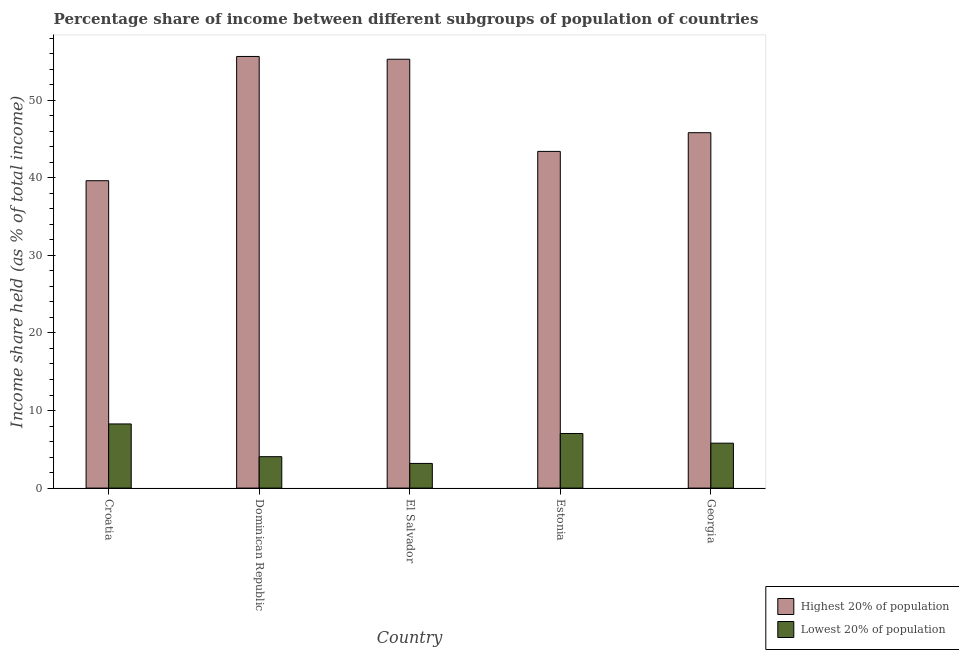How many groups of bars are there?
Provide a succinct answer. 5. How many bars are there on the 2nd tick from the left?
Offer a very short reply. 2. What is the label of the 2nd group of bars from the left?
Offer a terse response. Dominican Republic. In how many cases, is the number of bars for a given country not equal to the number of legend labels?
Your answer should be compact. 0. What is the income share held by highest 20% of the population in Croatia?
Your response must be concise. 39.63. Across all countries, what is the maximum income share held by highest 20% of the population?
Your answer should be very brief. 55.65. Across all countries, what is the minimum income share held by highest 20% of the population?
Your answer should be compact. 39.63. In which country was the income share held by lowest 20% of the population maximum?
Provide a short and direct response. Croatia. In which country was the income share held by highest 20% of the population minimum?
Your answer should be very brief. Croatia. What is the total income share held by highest 20% of the population in the graph?
Offer a terse response. 239.8. What is the difference between the income share held by lowest 20% of the population in Croatia and that in Estonia?
Your answer should be compact. 1.23. What is the difference between the income share held by highest 20% of the population in Estonia and the income share held by lowest 20% of the population in Croatia?
Provide a short and direct response. 35.14. What is the average income share held by lowest 20% of the population per country?
Ensure brevity in your answer.  5.67. What is the difference between the income share held by highest 20% of the population and income share held by lowest 20% of the population in El Salvador?
Offer a terse response. 52.11. In how many countries, is the income share held by highest 20% of the population greater than 38 %?
Give a very brief answer. 5. What is the ratio of the income share held by lowest 20% of the population in El Salvador to that in Georgia?
Your response must be concise. 0.55. Is the income share held by lowest 20% of the population in El Salvador less than that in Georgia?
Give a very brief answer. Yes. Is the difference between the income share held by lowest 20% of the population in Dominican Republic and Estonia greater than the difference between the income share held by highest 20% of the population in Dominican Republic and Estonia?
Your answer should be compact. No. What is the difference between the highest and the second highest income share held by highest 20% of the population?
Keep it short and to the point. 0.36. What is the difference between the highest and the lowest income share held by lowest 20% of the population?
Your answer should be compact. 5.09. In how many countries, is the income share held by highest 20% of the population greater than the average income share held by highest 20% of the population taken over all countries?
Offer a terse response. 2. Is the sum of the income share held by lowest 20% of the population in Croatia and El Salvador greater than the maximum income share held by highest 20% of the population across all countries?
Provide a succinct answer. No. What does the 2nd bar from the left in Estonia represents?
Provide a short and direct response. Lowest 20% of population. What does the 1st bar from the right in Croatia represents?
Ensure brevity in your answer.  Lowest 20% of population. Are all the bars in the graph horizontal?
Make the answer very short. No. How many countries are there in the graph?
Your response must be concise. 5. What is the difference between two consecutive major ticks on the Y-axis?
Keep it short and to the point. 10. Are the values on the major ticks of Y-axis written in scientific E-notation?
Make the answer very short. No. How many legend labels are there?
Offer a terse response. 2. How are the legend labels stacked?
Offer a terse response. Vertical. What is the title of the graph?
Your answer should be very brief. Percentage share of income between different subgroups of population of countries. Does "Merchandise exports" appear as one of the legend labels in the graph?
Ensure brevity in your answer.  No. What is the label or title of the Y-axis?
Ensure brevity in your answer.  Income share held (as % of total income). What is the Income share held (as % of total income) in Highest 20% of population in Croatia?
Your answer should be very brief. 39.63. What is the Income share held (as % of total income) of Lowest 20% of population in Croatia?
Your answer should be compact. 8.27. What is the Income share held (as % of total income) of Highest 20% of population in Dominican Republic?
Give a very brief answer. 55.65. What is the Income share held (as % of total income) in Lowest 20% of population in Dominican Republic?
Offer a very short reply. 4.05. What is the Income share held (as % of total income) of Highest 20% of population in El Salvador?
Ensure brevity in your answer.  55.29. What is the Income share held (as % of total income) of Lowest 20% of population in El Salvador?
Offer a very short reply. 3.18. What is the Income share held (as % of total income) of Highest 20% of population in Estonia?
Make the answer very short. 43.41. What is the Income share held (as % of total income) of Lowest 20% of population in Estonia?
Provide a short and direct response. 7.04. What is the Income share held (as % of total income) in Highest 20% of population in Georgia?
Your response must be concise. 45.82. What is the Income share held (as % of total income) in Lowest 20% of population in Georgia?
Offer a terse response. 5.79. Across all countries, what is the maximum Income share held (as % of total income) in Highest 20% of population?
Offer a very short reply. 55.65. Across all countries, what is the maximum Income share held (as % of total income) of Lowest 20% of population?
Provide a succinct answer. 8.27. Across all countries, what is the minimum Income share held (as % of total income) in Highest 20% of population?
Your response must be concise. 39.63. Across all countries, what is the minimum Income share held (as % of total income) in Lowest 20% of population?
Your response must be concise. 3.18. What is the total Income share held (as % of total income) in Highest 20% of population in the graph?
Provide a succinct answer. 239.8. What is the total Income share held (as % of total income) in Lowest 20% of population in the graph?
Give a very brief answer. 28.33. What is the difference between the Income share held (as % of total income) of Highest 20% of population in Croatia and that in Dominican Republic?
Keep it short and to the point. -16.02. What is the difference between the Income share held (as % of total income) in Lowest 20% of population in Croatia and that in Dominican Republic?
Ensure brevity in your answer.  4.22. What is the difference between the Income share held (as % of total income) in Highest 20% of population in Croatia and that in El Salvador?
Your answer should be compact. -15.66. What is the difference between the Income share held (as % of total income) of Lowest 20% of population in Croatia and that in El Salvador?
Your answer should be compact. 5.09. What is the difference between the Income share held (as % of total income) of Highest 20% of population in Croatia and that in Estonia?
Make the answer very short. -3.78. What is the difference between the Income share held (as % of total income) of Lowest 20% of population in Croatia and that in Estonia?
Your answer should be very brief. 1.23. What is the difference between the Income share held (as % of total income) of Highest 20% of population in Croatia and that in Georgia?
Provide a short and direct response. -6.19. What is the difference between the Income share held (as % of total income) of Lowest 20% of population in Croatia and that in Georgia?
Offer a terse response. 2.48. What is the difference between the Income share held (as % of total income) of Highest 20% of population in Dominican Republic and that in El Salvador?
Your answer should be very brief. 0.36. What is the difference between the Income share held (as % of total income) of Lowest 20% of population in Dominican Republic and that in El Salvador?
Offer a terse response. 0.87. What is the difference between the Income share held (as % of total income) in Highest 20% of population in Dominican Republic and that in Estonia?
Your answer should be compact. 12.24. What is the difference between the Income share held (as % of total income) of Lowest 20% of population in Dominican Republic and that in Estonia?
Your response must be concise. -2.99. What is the difference between the Income share held (as % of total income) of Highest 20% of population in Dominican Republic and that in Georgia?
Offer a terse response. 9.83. What is the difference between the Income share held (as % of total income) in Lowest 20% of population in Dominican Republic and that in Georgia?
Keep it short and to the point. -1.74. What is the difference between the Income share held (as % of total income) in Highest 20% of population in El Salvador and that in Estonia?
Your answer should be compact. 11.88. What is the difference between the Income share held (as % of total income) in Lowest 20% of population in El Salvador and that in Estonia?
Offer a terse response. -3.86. What is the difference between the Income share held (as % of total income) in Highest 20% of population in El Salvador and that in Georgia?
Offer a very short reply. 9.47. What is the difference between the Income share held (as % of total income) in Lowest 20% of population in El Salvador and that in Georgia?
Your answer should be compact. -2.61. What is the difference between the Income share held (as % of total income) in Highest 20% of population in Estonia and that in Georgia?
Keep it short and to the point. -2.41. What is the difference between the Income share held (as % of total income) in Lowest 20% of population in Estonia and that in Georgia?
Offer a terse response. 1.25. What is the difference between the Income share held (as % of total income) of Highest 20% of population in Croatia and the Income share held (as % of total income) of Lowest 20% of population in Dominican Republic?
Ensure brevity in your answer.  35.58. What is the difference between the Income share held (as % of total income) in Highest 20% of population in Croatia and the Income share held (as % of total income) in Lowest 20% of population in El Salvador?
Your answer should be very brief. 36.45. What is the difference between the Income share held (as % of total income) in Highest 20% of population in Croatia and the Income share held (as % of total income) in Lowest 20% of population in Estonia?
Make the answer very short. 32.59. What is the difference between the Income share held (as % of total income) of Highest 20% of population in Croatia and the Income share held (as % of total income) of Lowest 20% of population in Georgia?
Offer a very short reply. 33.84. What is the difference between the Income share held (as % of total income) of Highest 20% of population in Dominican Republic and the Income share held (as % of total income) of Lowest 20% of population in El Salvador?
Your answer should be very brief. 52.47. What is the difference between the Income share held (as % of total income) in Highest 20% of population in Dominican Republic and the Income share held (as % of total income) in Lowest 20% of population in Estonia?
Make the answer very short. 48.61. What is the difference between the Income share held (as % of total income) in Highest 20% of population in Dominican Republic and the Income share held (as % of total income) in Lowest 20% of population in Georgia?
Keep it short and to the point. 49.86. What is the difference between the Income share held (as % of total income) of Highest 20% of population in El Salvador and the Income share held (as % of total income) of Lowest 20% of population in Estonia?
Ensure brevity in your answer.  48.25. What is the difference between the Income share held (as % of total income) in Highest 20% of population in El Salvador and the Income share held (as % of total income) in Lowest 20% of population in Georgia?
Offer a terse response. 49.5. What is the difference between the Income share held (as % of total income) in Highest 20% of population in Estonia and the Income share held (as % of total income) in Lowest 20% of population in Georgia?
Your answer should be compact. 37.62. What is the average Income share held (as % of total income) of Highest 20% of population per country?
Offer a terse response. 47.96. What is the average Income share held (as % of total income) in Lowest 20% of population per country?
Provide a succinct answer. 5.67. What is the difference between the Income share held (as % of total income) of Highest 20% of population and Income share held (as % of total income) of Lowest 20% of population in Croatia?
Give a very brief answer. 31.36. What is the difference between the Income share held (as % of total income) of Highest 20% of population and Income share held (as % of total income) of Lowest 20% of population in Dominican Republic?
Ensure brevity in your answer.  51.6. What is the difference between the Income share held (as % of total income) of Highest 20% of population and Income share held (as % of total income) of Lowest 20% of population in El Salvador?
Ensure brevity in your answer.  52.11. What is the difference between the Income share held (as % of total income) of Highest 20% of population and Income share held (as % of total income) of Lowest 20% of population in Estonia?
Your response must be concise. 36.37. What is the difference between the Income share held (as % of total income) of Highest 20% of population and Income share held (as % of total income) of Lowest 20% of population in Georgia?
Provide a succinct answer. 40.03. What is the ratio of the Income share held (as % of total income) of Highest 20% of population in Croatia to that in Dominican Republic?
Your answer should be compact. 0.71. What is the ratio of the Income share held (as % of total income) of Lowest 20% of population in Croatia to that in Dominican Republic?
Keep it short and to the point. 2.04. What is the ratio of the Income share held (as % of total income) of Highest 20% of population in Croatia to that in El Salvador?
Your answer should be compact. 0.72. What is the ratio of the Income share held (as % of total income) in Lowest 20% of population in Croatia to that in El Salvador?
Offer a very short reply. 2.6. What is the ratio of the Income share held (as % of total income) in Highest 20% of population in Croatia to that in Estonia?
Your answer should be very brief. 0.91. What is the ratio of the Income share held (as % of total income) of Lowest 20% of population in Croatia to that in Estonia?
Provide a succinct answer. 1.17. What is the ratio of the Income share held (as % of total income) in Highest 20% of population in Croatia to that in Georgia?
Your answer should be very brief. 0.86. What is the ratio of the Income share held (as % of total income) of Lowest 20% of population in Croatia to that in Georgia?
Your answer should be very brief. 1.43. What is the ratio of the Income share held (as % of total income) of Lowest 20% of population in Dominican Republic to that in El Salvador?
Provide a succinct answer. 1.27. What is the ratio of the Income share held (as % of total income) of Highest 20% of population in Dominican Republic to that in Estonia?
Give a very brief answer. 1.28. What is the ratio of the Income share held (as % of total income) of Lowest 20% of population in Dominican Republic to that in Estonia?
Keep it short and to the point. 0.58. What is the ratio of the Income share held (as % of total income) of Highest 20% of population in Dominican Republic to that in Georgia?
Make the answer very short. 1.21. What is the ratio of the Income share held (as % of total income) in Lowest 20% of population in Dominican Republic to that in Georgia?
Give a very brief answer. 0.7. What is the ratio of the Income share held (as % of total income) in Highest 20% of population in El Salvador to that in Estonia?
Your answer should be very brief. 1.27. What is the ratio of the Income share held (as % of total income) of Lowest 20% of population in El Salvador to that in Estonia?
Your answer should be compact. 0.45. What is the ratio of the Income share held (as % of total income) in Highest 20% of population in El Salvador to that in Georgia?
Offer a terse response. 1.21. What is the ratio of the Income share held (as % of total income) of Lowest 20% of population in El Salvador to that in Georgia?
Provide a succinct answer. 0.55. What is the ratio of the Income share held (as % of total income) in Highest 20% of population in Estonia to that in Georgia?
Your answer should be very brief. 0.95. What is the ratio of the Income share held (as % of total income) in Lowest 20% of population in Estonia to that in Georgia?
Your answer should be very brief. 1.22. What is the difference between the highest and the second highest Income share held (as % of total income) of Highest 20% of population?
Give a very brief answer. 0.36. What is the difference between the highest and the second highest Income share held (as % of total income) of Lowest 20% of population?
Make the answer very short. 1.23. What is the difference between the highest and the lowest Income share held (as % of total income) in Highest 20% of population?
Offer a very short reply. 16.02. What is the difference between the highest and the lowest Income share held (as % of total income) of Lowest 20% of population?
Give a very brief answer. 5.09. 